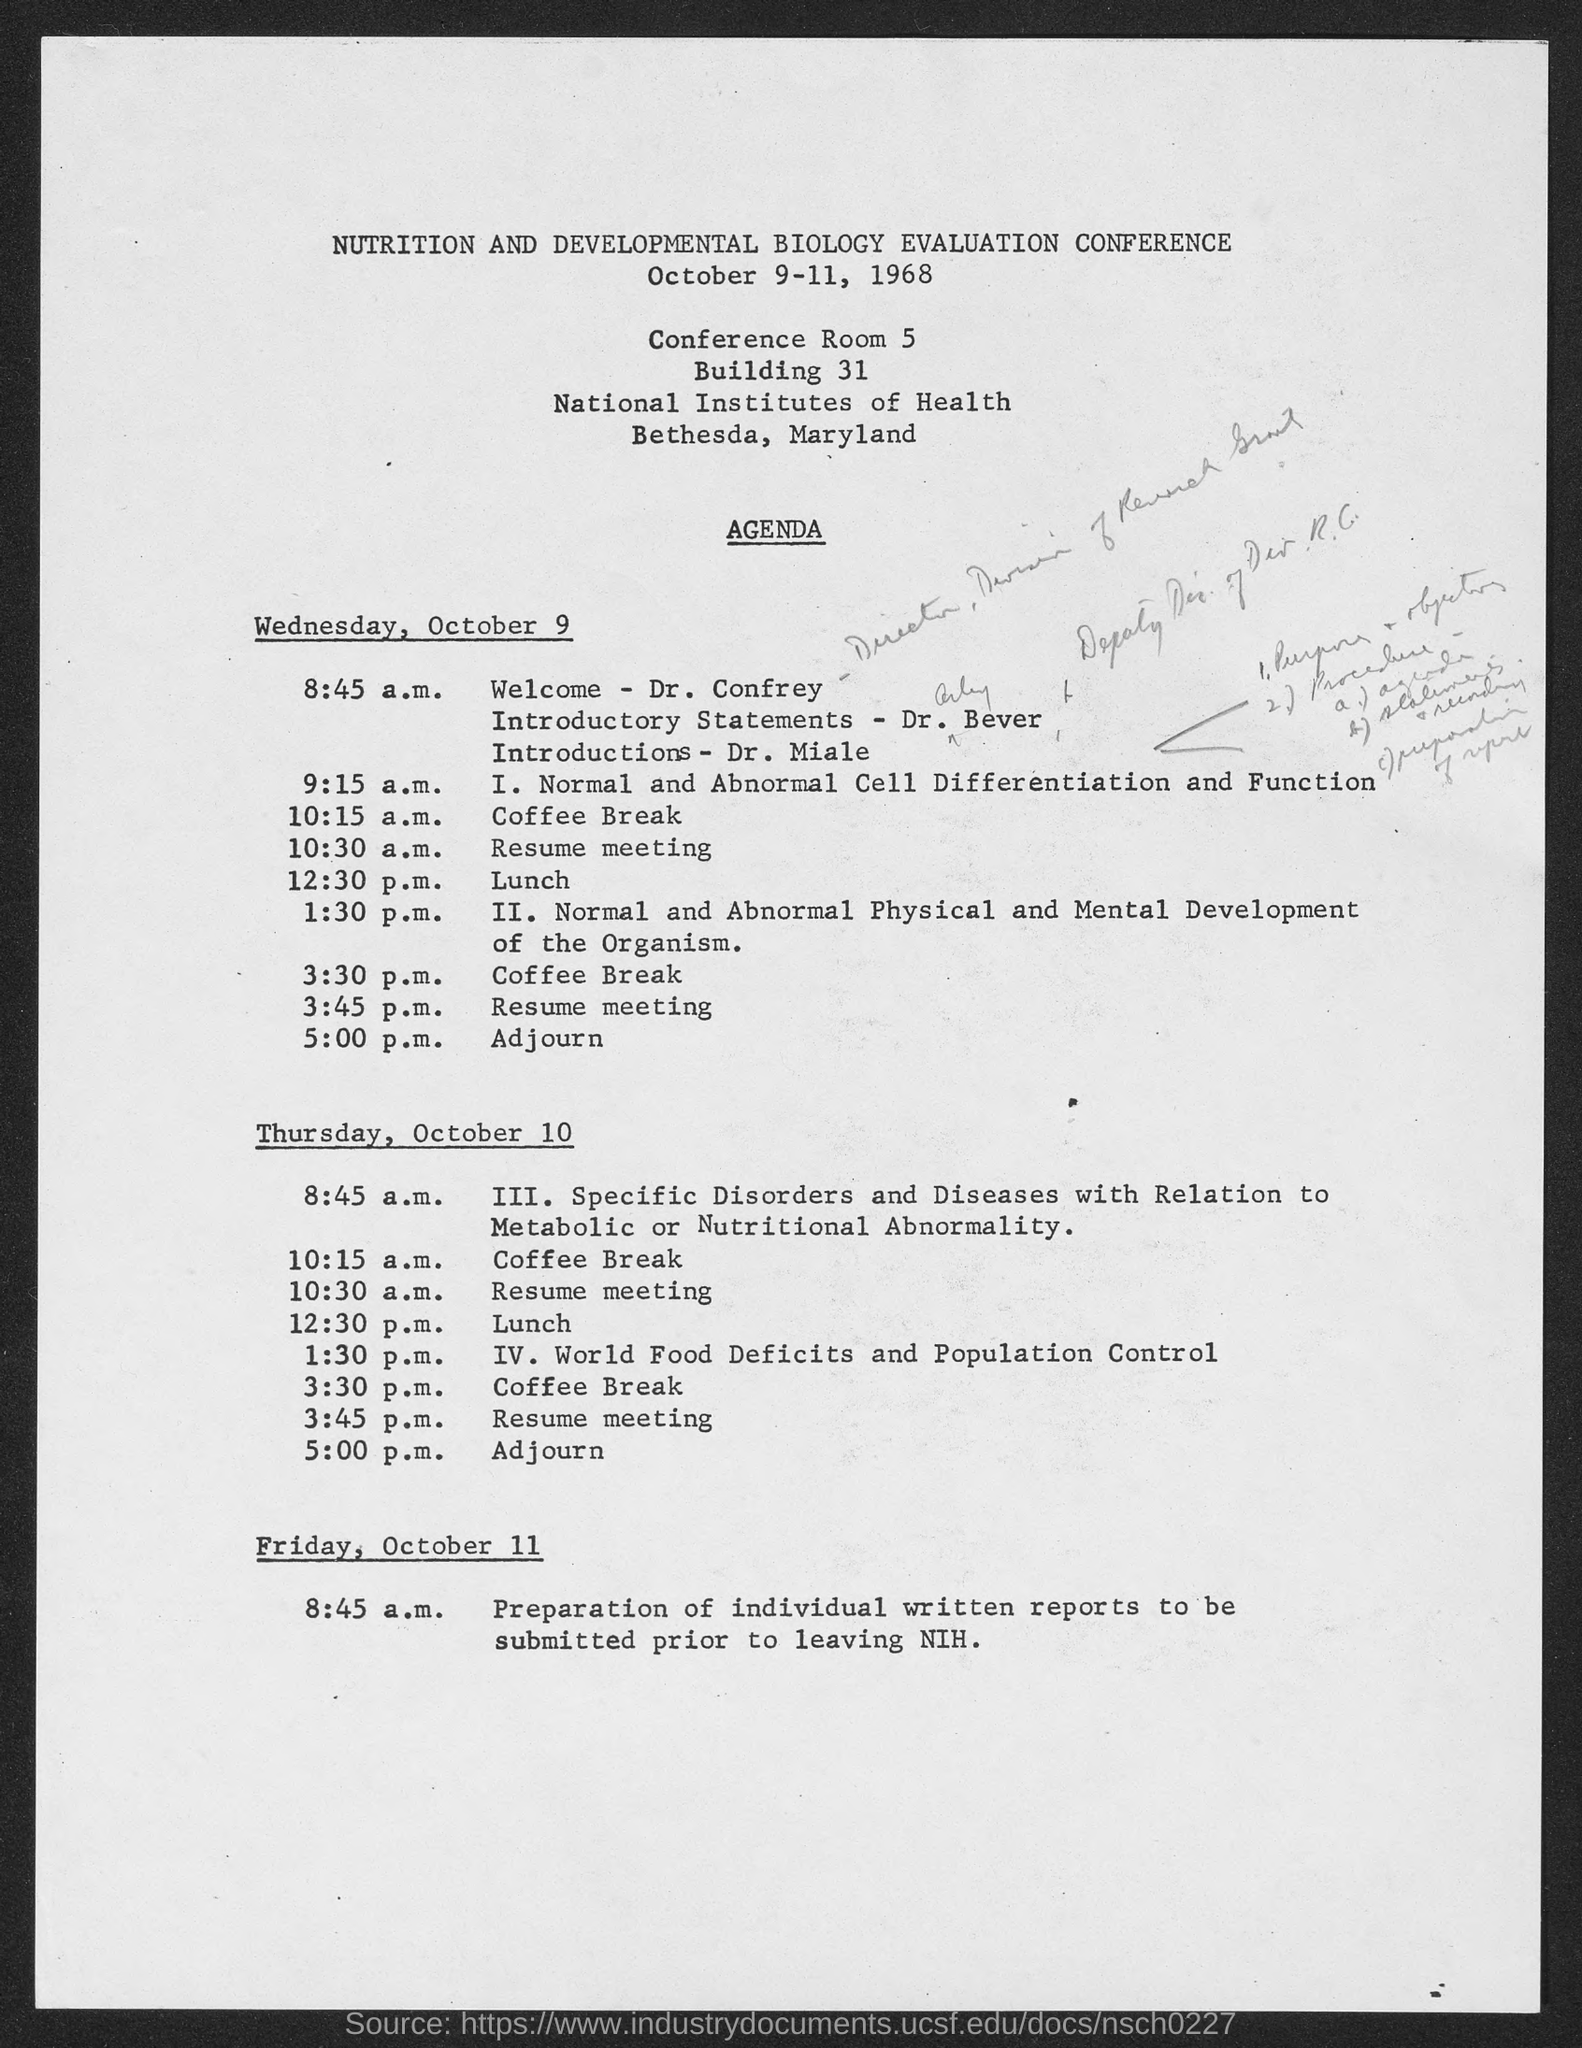Outline some significant characteristics in this image. The IV session, which was conducted at 1:30 p.m. on Thursday, October 10, covered the topic of World Food Deficits and Population Control. The welcoming address for the session is being given by Dr. Confrey. On Wednesday, October 9, the session that was conducted at 9:15 a.m. was "Normal and Abnormal Cell Differentiation and Function. The Nutrition and Developmental Biology Evaluation Conference was held from October 9-11, 1968. 